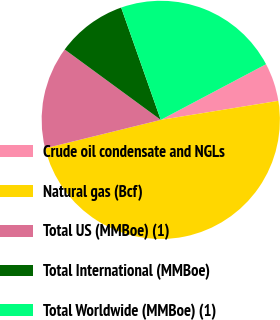<chart> <loc_0><loc_0><loc_500><loc_500><pie_chart><fcel>Crude oil condensate and NGLs<fcel>Natural gas (Bcf)<fcel>Total US (MMBoe) (1)<fcel>Total International (MMBoe)<fcel>Total Worldwide (MMBoe) (1)<nl><fcel>5.19%<fcel>48.72%<fcel>13.9%<fcel>9.54%<fcel>22.65%<nl></chart> 